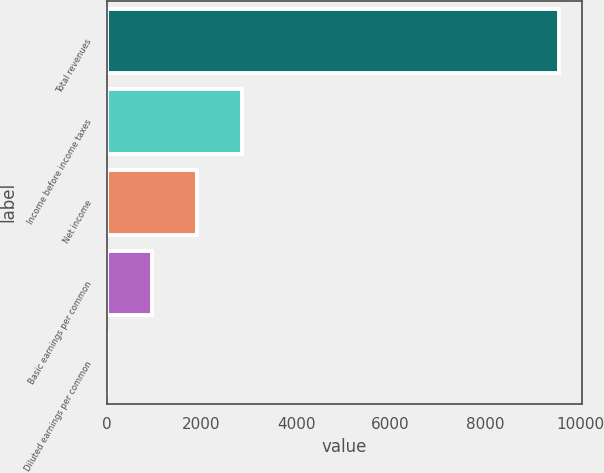Convert chart to OTSL. <chart><loc_0><loc_0><loc_500><loc_500><bar_chart><fcel>Total revenues<fcel>Income before income taxes<fcel>Net income<fcel>Basic earnings per common<fcel>Diluted earnings per common<nl><fcel>9557<fcel>2867.93<fcel>1912.35<fcel>956.77<fcel>1.19<nl></chart> 